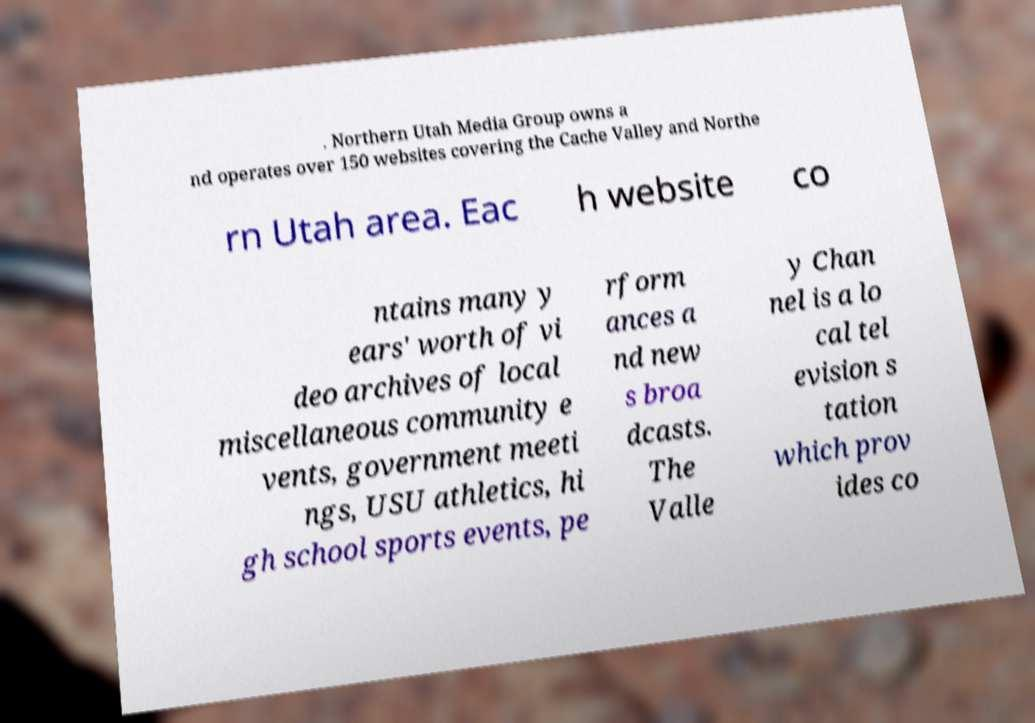Could you extract and type out the text from this image? . Northern Utah Media Group owns a nd operates over 150 websites covering the Cache Valley and Northe rn Utah area. Eac h website co ntains many y ears' worth of vi deo archives of local miscellaneous community e vents, government meeti ngs, USU athletics, hi gh school sports events, pe rform ances a nd new s broa dcasts. The Valle y Chan nel is a lo cal tel evision s tation which prov ides co 